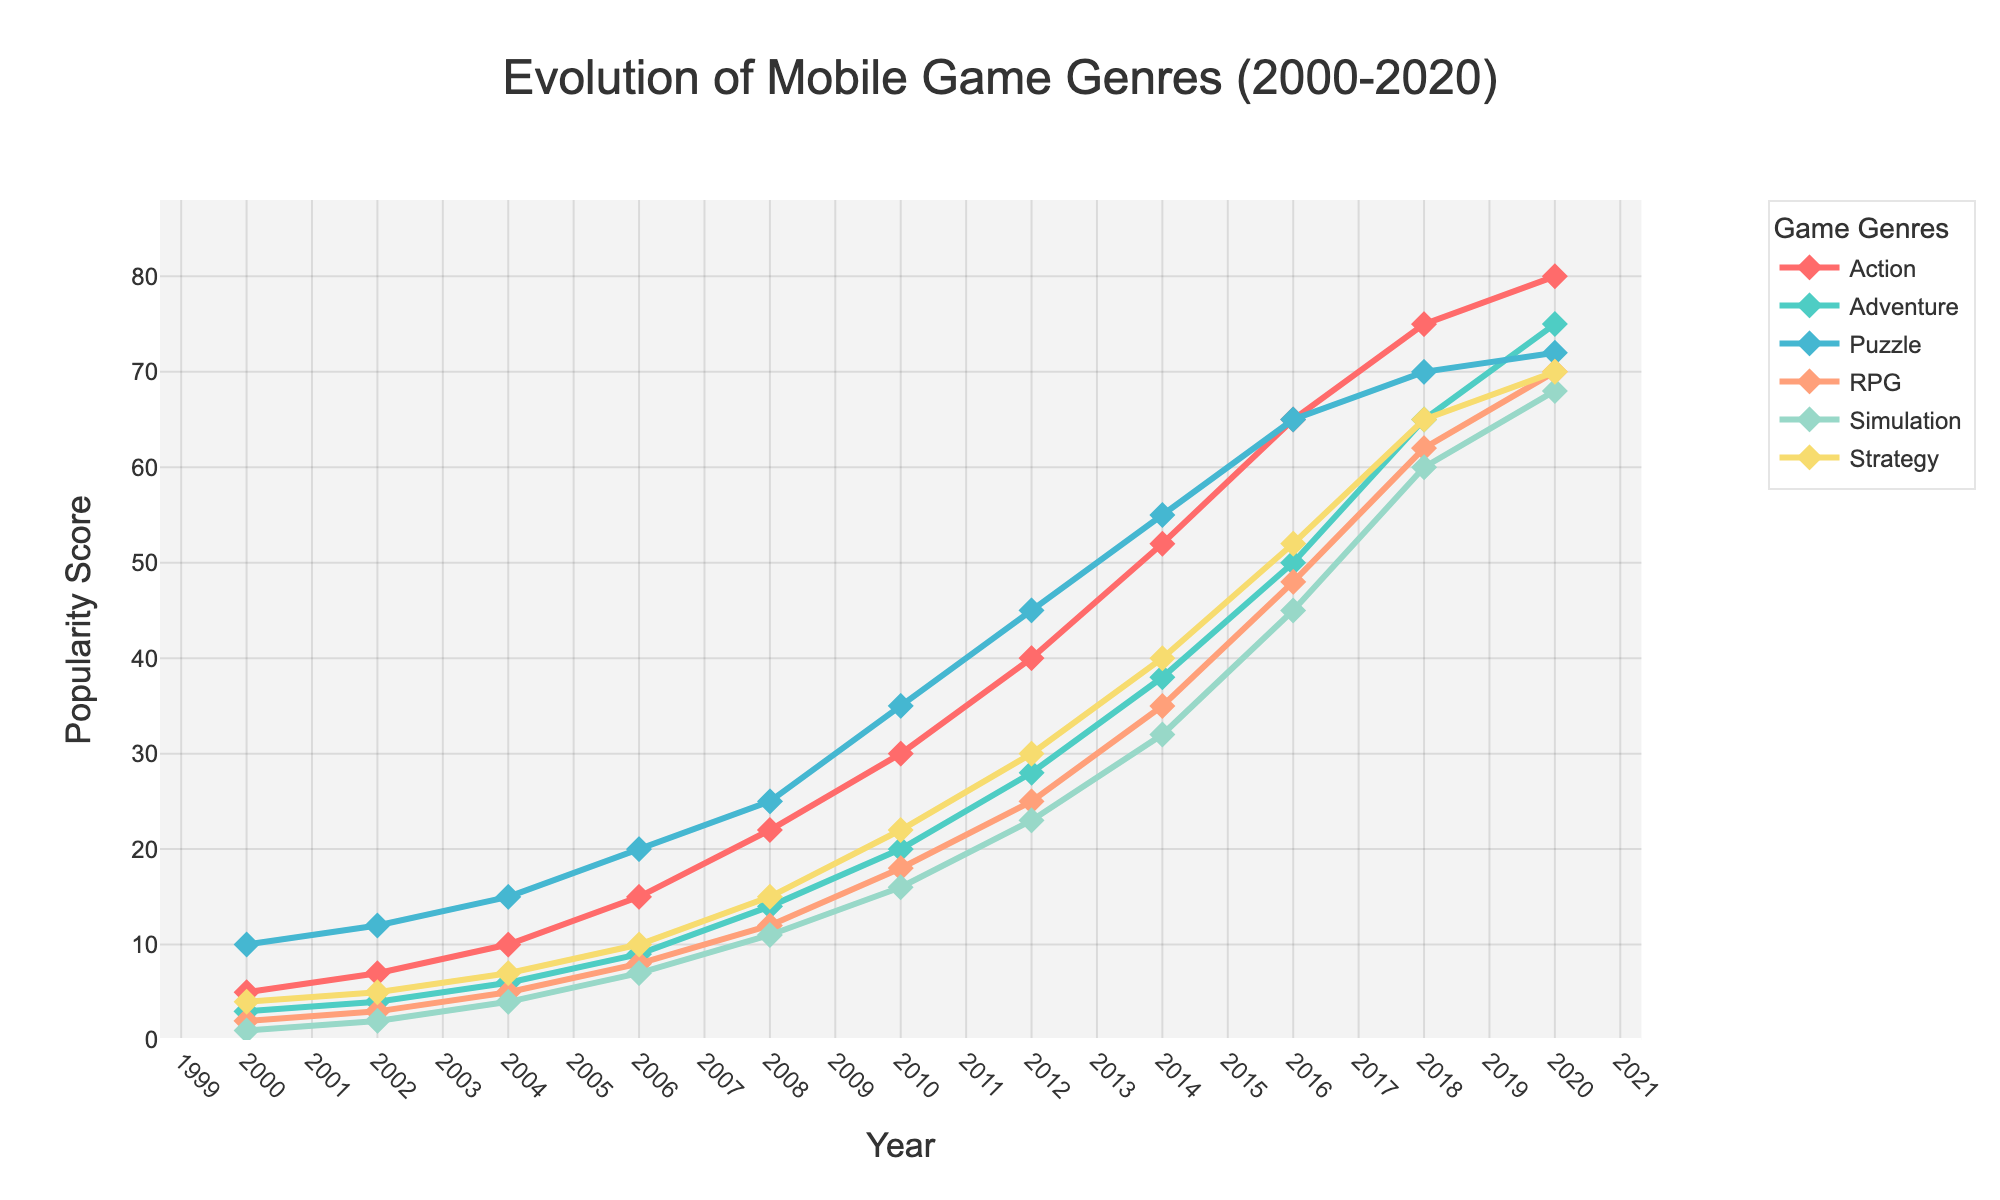what trend do you observe for the popularity of puzzle games from 2000 to 2020? The popularity of puzzle games shows a consistent upward trend from 2000 to 2020, increasing from 10 to 72.
Answer: Consistent upward trend Which genre had the highest popularity score in 2000 and how much was it? In 2000, the puzzle genre had the highest popularity score, with a score of 10.
Answer: Puzzle, 10 What is the difference in popularity between action and simulation games in 2010? In 2010, the popularity score for action games is 30 and for simulation games is 16. The difference is calculated by 30 - 16 = 14.
Answer: 14 Between which years does the adventure genre show the most significant growth? From 2006 to 2008, there is a significant growth in the popularity of adventure games, from 9 to 14. The increase during this period is 5, the largest observed across the periods.
Answer: 2006 to 2008 Compare the popularity trends of RPG and Strategy genres from 2000 to 2020? RPG and Strategy genres both show a rising trend, but RPG experiences a more rapid increase, particularly from 2014 onwards. By 2020, RPG reaches 70, while Strategy reaches 70, but with a steadier growth rate.
Answer: RPG, more rapid What is the combined popularity score of Adventure and Simulation in 2016? In 2016, the popularity scores for Adventure and Simulation games are 50 and 45 respectively. The combined score is 50 + 45 = 95.
Answer: 95 Which genre had the least increase in popularity over the two decades? Comparing the increase in popularity, Puzzle started at 10 in 2000 and ended at 72 in 2020. This represents the smallest net increase: 72 - 10 = 62.
Answer: Puzzle Are the popularity scores of Strategy and Adventure games ever equal in any of the years? Observing the figure for the years from 2000 to 2020, there is no year where the popularity scores of Strategy and Adventure games are equal.
Answer: No What was the percentage increase in the popularity of Action games from 2000 to 2020? The popularity of Action games in 2000 was 5 and in 2020 it was 80. The percentage increase can be calculated as [(80 - 5) / 5] * 100 ≈ 1500%.
Answer: 1500% In 2018, which genre surpassed the 60 popularity score mark, and how many genres achieved this? In 2018, the genres that surpassed the 60 popularity score mark are Action (75), Adventure (65), RPG (62), and Simulation (60). This makes a total of 4 genres.
Answer: Action, Adventure, RPG, Simulation; 4 